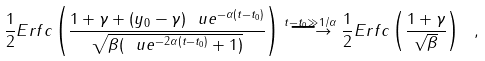Convert formula to latex. <formula><loc_0><loc_0><loc_500><loc_500>\frac { 1 } { 2 } E r f c \left ( \frac { 1 + \gamma + ( y _ { 0 } - \gamma ) \ u e ^ { - \alpha ( t - t _ { 0 } ) } } { \sqrt { \beta ( \ u e ^ { - 2 \alpha ( t - t _ { 0 } ) } + 1 ) } } \right ) \stackrel { t - t _ { 0 } \gg 1 / \alpha } { \longrightarrow } \frac { 1 } { 2 } E r f c \left ( \frac { 1 + \gamma } { \sqrt { \beta } } \right ) \ ,</formula> 